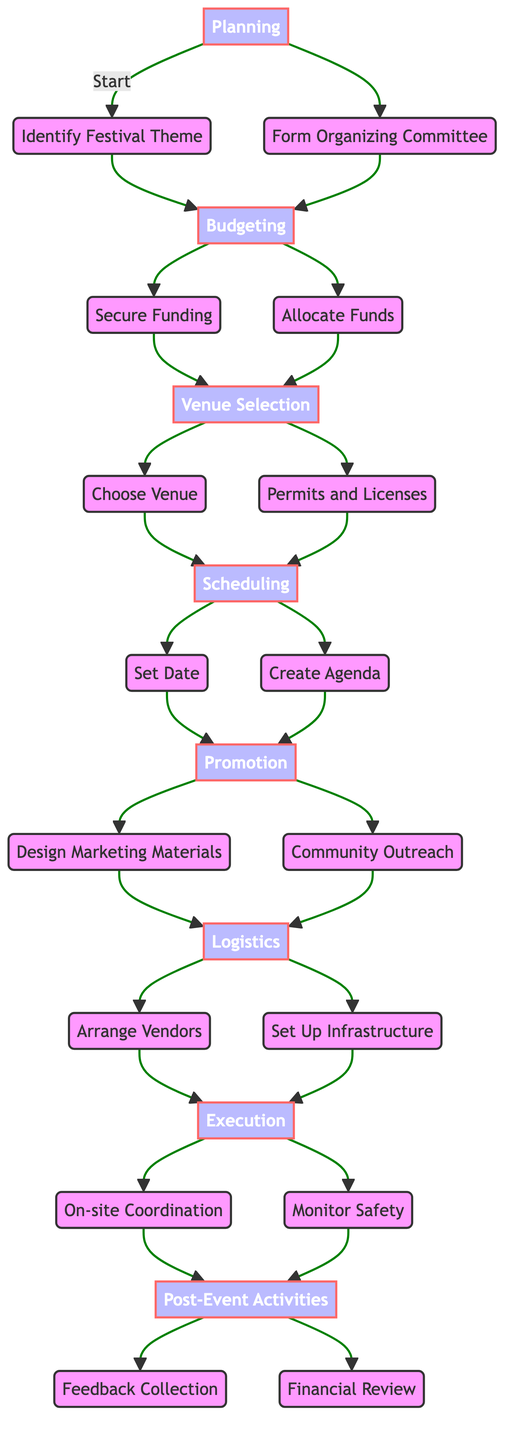What is the first step in organizing the town festival? The diagram shows that the first step under the "Planning" phase is "Identify Festival Theme." This is the initial action that triggers the subsequent steps in the festival organization process.
Answer: Identify Festival Theme How many nodes are there in the Budgeting phase? By examining the diagram, we can see that the "Budgeting" phase has two distinct nodes: "Secure Funding" and "Allocate Funds." Thus, there are two nodes in this phase.
Answer: 2 Which node follows "Set Date"? According to the flow chart, "Create Agenda" directly follows the "Set Date" node within the "Scheduling" phase, indicating the sequence of actions to take after selecting a festival date.
Answer: Create Agenda What are the two main components of the Promotion phase? The diagram illustrates that the "Promotion" phase splits into two components: "Design Marketing Materials" and "Community Outreach." These two tasks are crucial for effectively promoting the festival.
Answer: Design Marketing Materials, Community Outreach How do "Arrange Vendors" and "Set Up Infrastructure" connect to the Execution phase? In the flow chart, both "Arrange Vendors" and "Set Up Infrastructure" precede the "Execution" phase. This indicates that these logistics need to be completed before entering the phase where the festival is actively managed and executed, leading both to "On-site Coordination" and "Monitor Safety."
Answer: They both lead to Execution What is the last activity in the Post-Event Activities phase? The diagram shows two nodes branching out from the "Post-Event Activities" phase: "Feedback Collection" and "Financial Review." This means that both are considered concluding activities following the festival.
Answer: Feedback Collection, Financial Review What is the purpose of the "Form Organizing Committee" step? "Form Organizing Committee" is important because it establishes a team that includes town officials, local business owners, and community leaders responsible for overseeing the festival planning and execution. This collaborative step is vital for ensuring a successful event.
Answer: Include town officials, local business owners, community leaders Which phases need to be completed before moving to Promotion? The diagram indicates that both the "Budgeting" and "Scheduling" phases must be finished before entering the "Promotion" phase. This order is necessary to ensure that all necessary funding and scheduling are established for effective promotional efforts.
Answer: Budgeting, Scheduling 